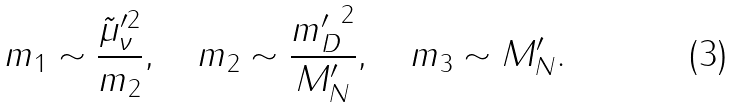Convert formula to latex. <formula><loc_0><loc_0><loc_500><loc_500>m _ { 1 } \sim \frac { { \tilde { \mu } } ^ { \prime { 2 } } _ { \nu } } { m _ { 2 } } , \quad m _ { 2 } \sim \frac { { m _ { D } ^ { \prime } } ^ { 2 } } { M _ { N } ^ { \prime } } , \quad m _ { 3 } \sim { M } _ { N } ^ { \prime } .</formula> 